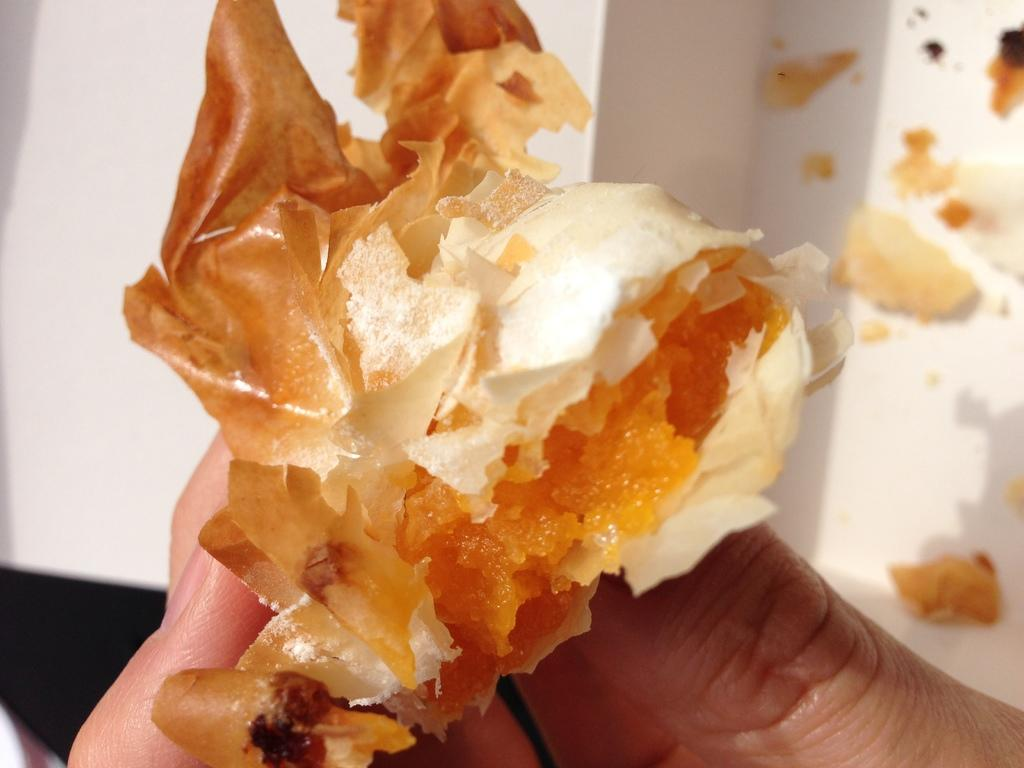What can be seen in the image that belongs to a person? There are fingers of a hand in the image. What are the fingers doing in the image? The fingers are holding a food item. What is visible in the background of the image? There is a box in the background of the image. What type of ball can be seen in the image? There is no ball present in the image. Can you describe the shape of the moon in the image? There is no moon present in the image. 